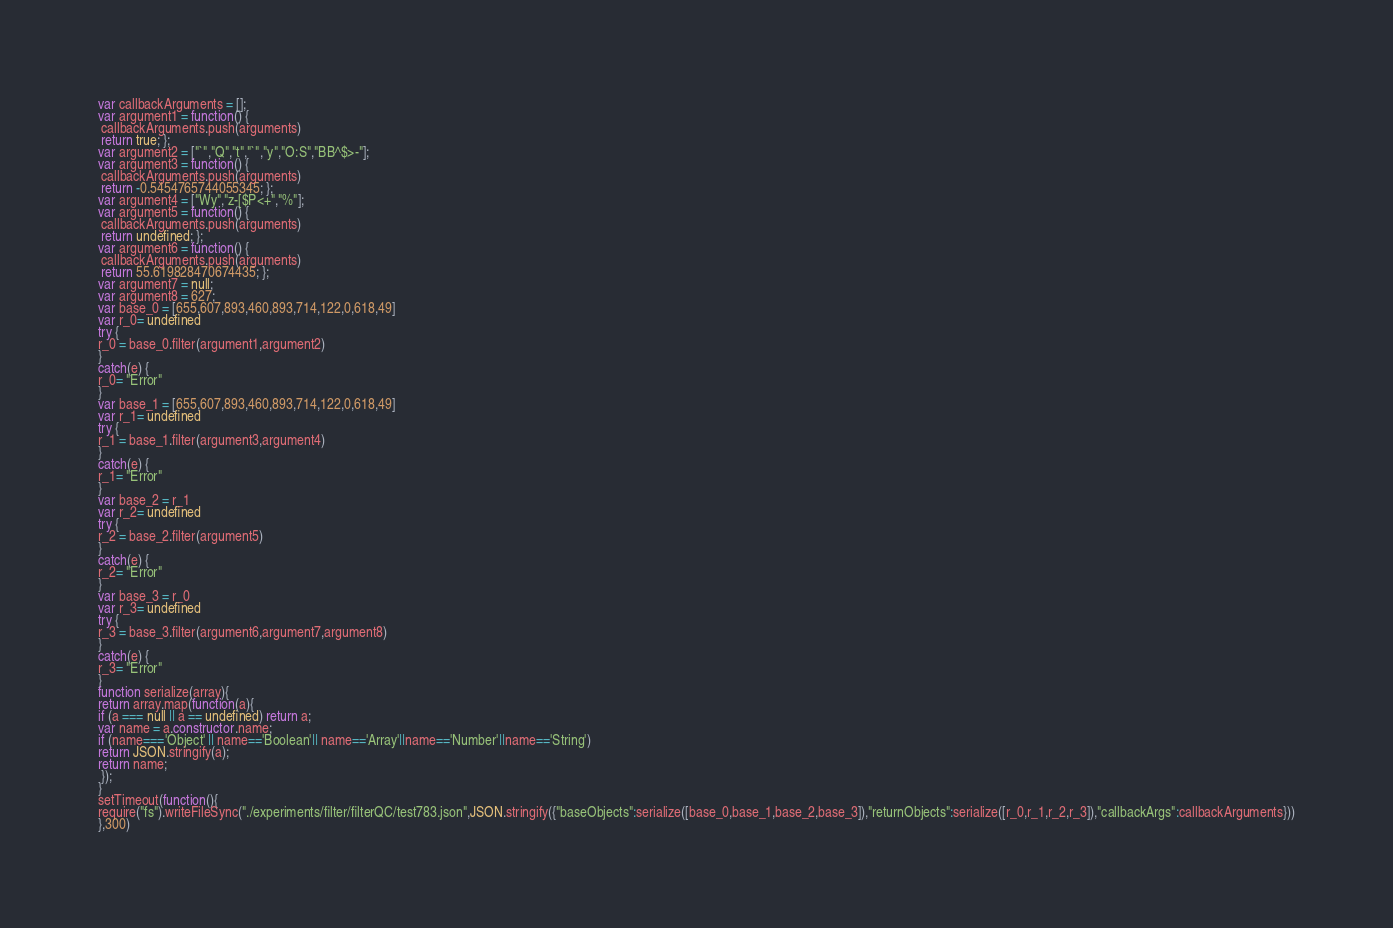Convert code to text. <code><loc_0><loc_0><loc_500><loc_500><_JavaScript_>





var callbackArguments = [];
var argument1 = function() {
 callbackArguments.push(arguments) 
 return true; };
var argument2 = ["`","Q","t","`","y","O:S","BB^$>-"];
var argument3 = function() {
 callbackArguments.push(arguments) 
 return -0.5454765744055345; };
var argument4 = ["Wy","z-[$P<+","%"];
var argument5 = function() {
 callbackArguments.push(arguments) 
 return undefined; };
var argument6 = function() {
 callbackArguments.push(arguments) 
 return 55.619828470674435; };
var argument7 = null;
var argument8 = 627;
var base_0 = [655,607,893,460,893,714,122,0,618,49]
var r_0= undefined
try {
r_0 = base_0.filter(argument1,argument2)
}
catch(e) {
r_0= "Error"
}
var base_1 = [655,607,893,460,893,714,122,0,618,49]
var r_1= undefined
try {
r_1 = base_1.filter(argument3,argument4)
}
catch(e) {
r_1= "Error"
}
var base_2 = r_1
var r_2= undefined
try {
r_2 = base_2.filter(argument5)
}
catch(e) {
r_2= "Error"
}
var base_3 = r_0
var r_3= undefined
try {
r_3 = base_3.filter(argument6,argument7,argument8)
}
catch(e) {
r_3= "Error"
}
function serialize(array){
return array.map(function(a){
if (a === null || a == undefined) return a;
var name = a.constructor.name;
if (name==='Object' || name=='Boolean'|| name=='Array'||name=='Number'||name=='String')
return JSON.stringify(a);
return name;
 });
}
setTimeout(function(){
require("fs").writeFileSync("./experiments/filter/filterQC/test783.json",JSON.stringify({"baseObjects":serialize([base_0,base_1,base_2,base_3]),"returnObjects":serialize([r_0,r_1,r_2,r_3]),"callbackArgs":callbackArguments}))
},300)</code> 